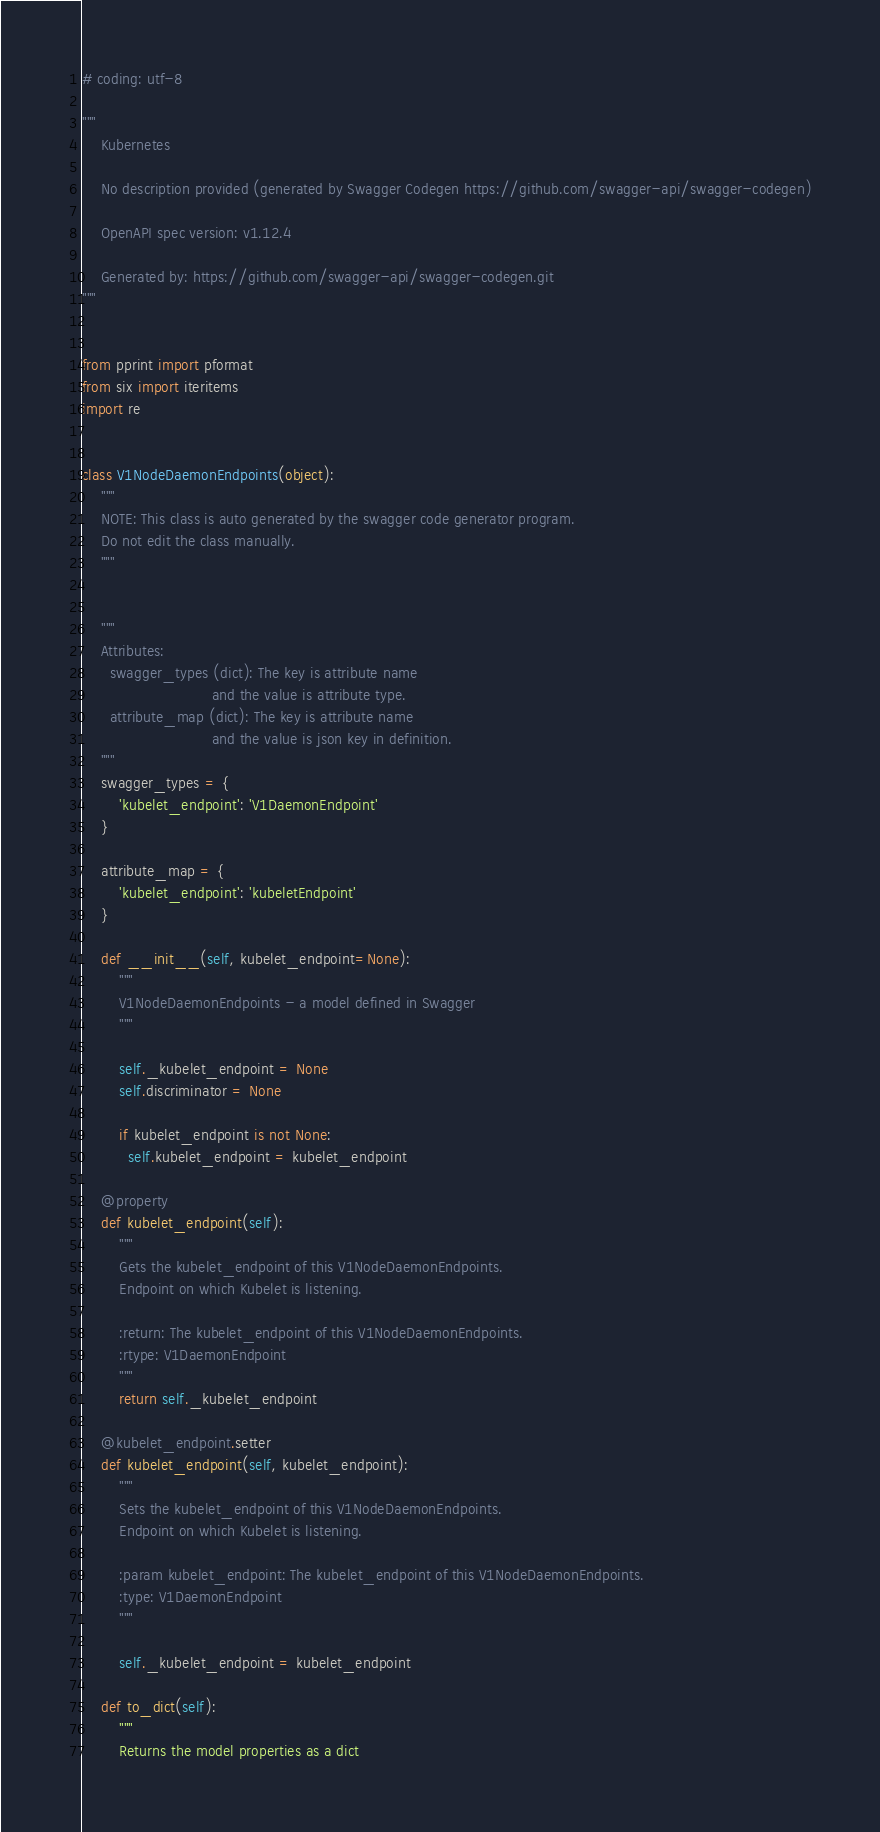<code> <loc_0><loc_0><loc_500><loc_500><_Python_># coding: utf-8

"""
    Kubernetes

    No description provided (generated by Swagger Codegen https://github.com/swagger-api/swagger-codegen)

    OpenAPI spec version: v1.12.4
    
    Generated by: https://github.com/swagger-api/swagger-codegen.git
"""


from pprint import pformat
from six import iteritems
import re


class V1NodeDaemonEndpoints(object):
    """
    NOTE: This class is auto generated by the swagger code generator program.
    Do not edit the class manually.
    """


    """
    Attributes:
      swagger_types (dict): The key is attribute name
                            and the value is attribute type.
      attribute_map (dict): The key is attribute name
                            and the value is json key in definition.
    """
    swagger_types = {
        'kubelet_endpoint': 'V1DaemonEndpoint'
    }

    attribute_map = {
        'kubelet_endpoint': 'kubeletEndpoint'
    }

    def __init__(self, kubelet_endpoint=None):
        """
        V1NodeDaemonEndpoints - a model defined in Swagger
        """

        self._kubelet_endpoint = None
        self.discriminator = None

        if kubelet_endpoint is not None:
          self.kubelet_endpoint = kubelet_endpoint

    @property
    def kubelet_endpoint(self):
        """
        Gets the kubelet_endpoint of this V1NodeDaemonEndpoints.
        Endpoint on which Kubelet is listening.

        :return: The kubelet_endpoint of this V1NodeDaemonEndpoints.
        :rtype: V1DaemonEndpoint
        """
        return self._kubelet_endpoint

    @kubelet_endpoint.setter
    def kubelet_endpoint(self, kubelet_endpoint):
        """
        Sets the kubelet_endpoint of this V1NodeDaemonEndpoints.
        Endpoint on which Kubelet is listening.

        :param kubelet_endpoint: The kubelet_endpoint of this V1NodeDaemonEndpoints.
        :type: V1DaemonEndpoint
        """

        self._kubelet_endpoint = kubelet_endpoint

    def to_dict(self):
        """
        Returns the model properties as a dict</code> 